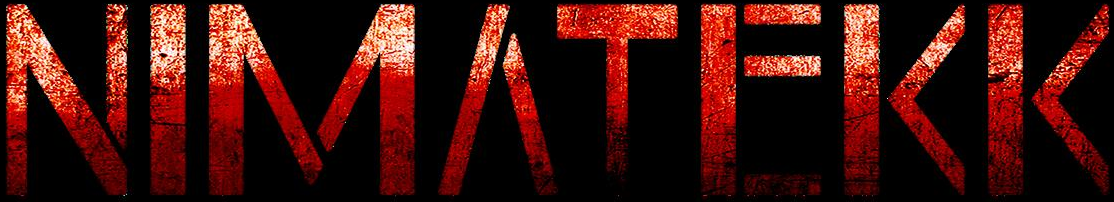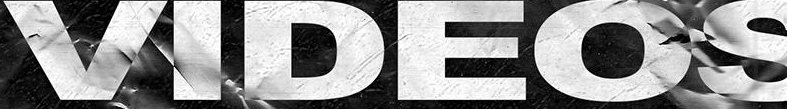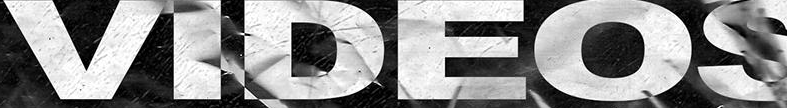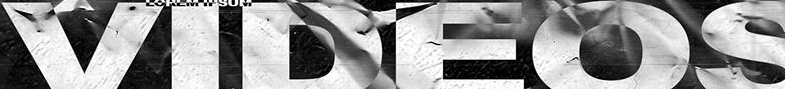Identify the words shown in these images in order, separated by a semicolon. NIMΛTEKK; VIDEOS; VIDEOS; VIDEOS 